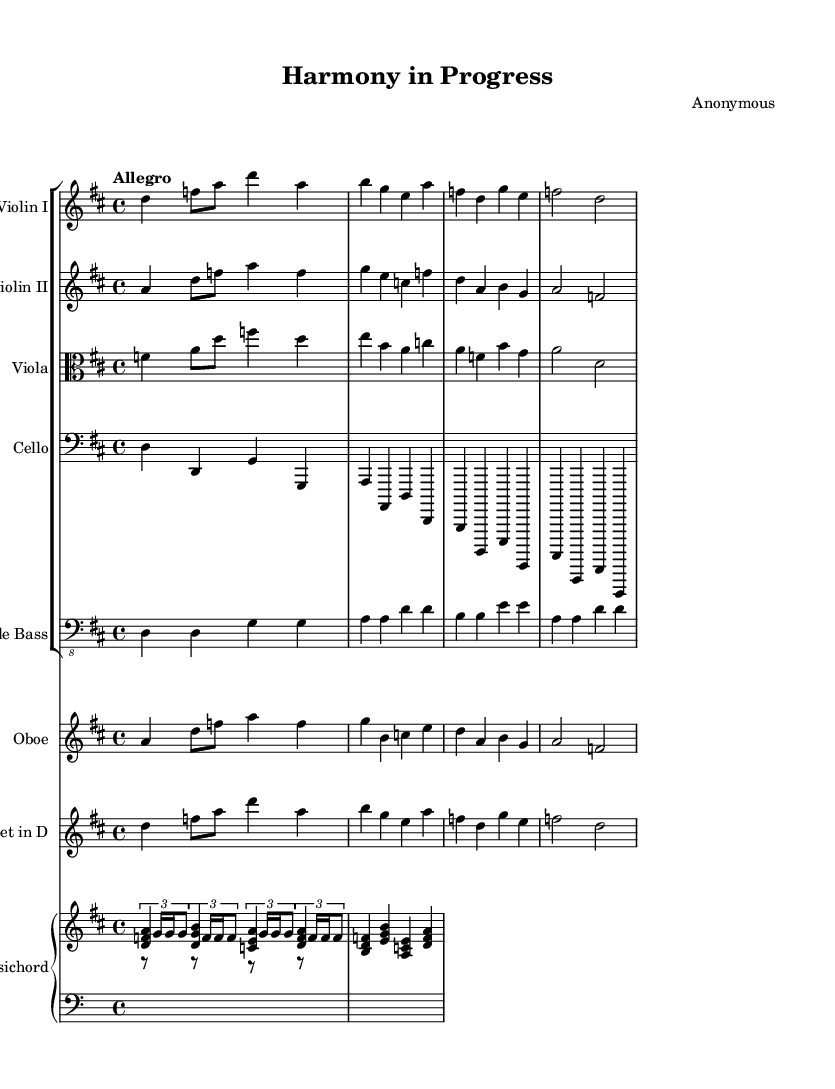What is the key signature of this piece? The key signature is indicated at the beginning of the score with two sharps, which represent F# and C#. Therefore, the piece is in the key of D major.
Answer: D major What is the time signature of the piece? The time signature is located near the beginning of the score, displayed as a "4/4". This means there are four beats in each measure, and a quarter note receives one beat.
Answer: 4/4 What is the tempo marking of the piece? The tempo marking is given in Italian style, written as "Allegro" above the score, indicating a fast, lively pace.
Answer: Allegro How many instruments are featured in this orchestral piece? By counting each different staff in the score, including violin I, violin II, viola, cello, double bass, oboe, trumpet, and harpsichord, we find there are a total of seven instruments.
Answer: Seven What is the overall texture used in this orchestral piece? The texture can be identified as polyphonic due to the interplay between multiple instrumental lines that perform distinct melodies simultaneously, typical of Baroque music.
Answer: Polyphonic Which instrument plays the lowest range in this composition? The double bass, indicated with a bass clef, plays the lowest range of notes within this orchestral setup, contributing the foundational bassline.
Answer: Double bass What does the use of a harpsichord indicate about the musical style? The inclusion of a harpsichord is a hallmark of Baroque music, as it was commonly used during this period to provide harmonic support and articulations typical of the style.
Answer: Baroque 